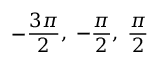Convert formula to latex. <formula><loc_0><loc_0><loc_500><loc_500>- { \frac { 3 \pi } { 2 } } , \, - { \frac { \pi } { 2 } } , \, { \frac { \pi } { 2 } }</formula> 